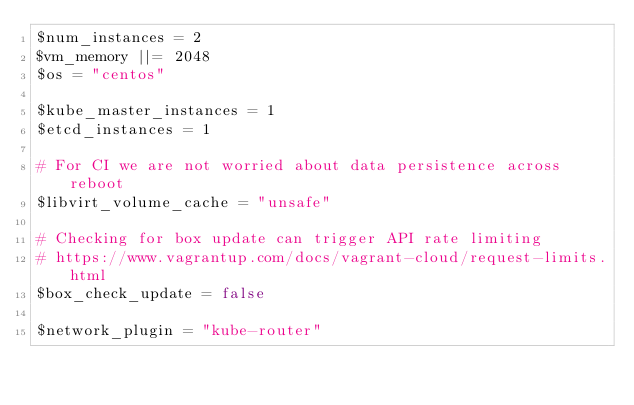Convert code to text. <code><loc_0><loc_0><loc_500><loc_500><_Ruby_>$num_instances = 2
$vm_memory ||= 2048
$os = "centos"

$kube_master_instances = 1
$etcd_instances = 1

# For CI we are not worried about data persistence across reboot
$libvirt_volume_cache = "unsafe"

# Checking for box update can trigger API rate limiting
# https://www.vagrantup.com/docs/vagrant-cloud/request-limits.html
$box_check_update = false

$network_plugin = "kube-router"
</code> 